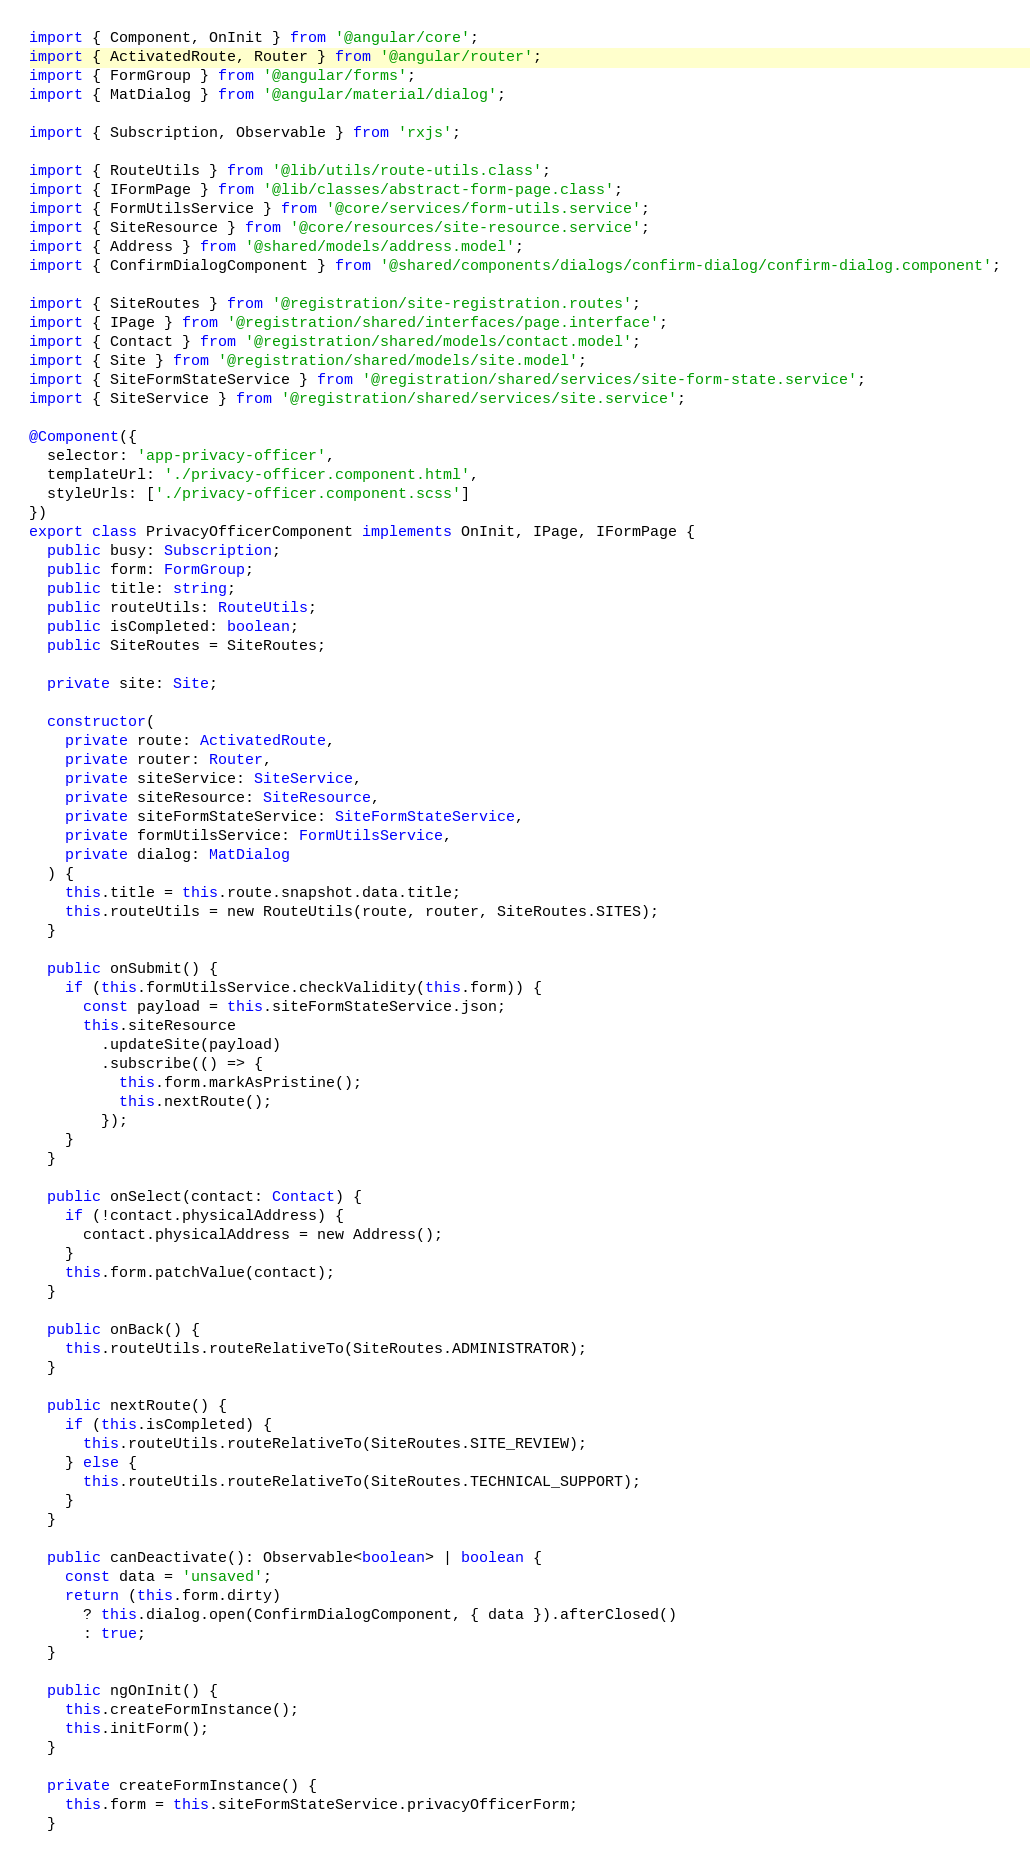Convert code to text. <code><loc_0><loc_0><loc_500><loc_500><_TypeScript_>import { Component, OnInit } from '@angular/core';
import { ActivatedRoute, Router } from '@angular/router';
import { FormGroup } from '@angular/forms';
import { MatDialog } from '@angular/material/dialog';

import { Subscription, Observable } from 'rxjs';

import { RouteUtils } from '@lib/utils/route-utils.class';
import { IFormPage } from '@lib/classes/abstract-form-page.class';
import { FormUtilsService } from '@core/services/form-utils.service';
import { SiteResource } from '@core/resources/site-resource.service';
import { Address } from '@shared/models/address.model';
import { ConfirmDialogComponent } from '@shared/components/dialogs/confirm-dialog/confirm-dialog.component';

import { SiteRoutes } from '@registration/site-registration.routes';
import { IPage } from '@registration/shared/interfaces/page.interface';
import { Contact } from '@registration/shared/models/contact.model';
import { Site } from '@registration/shared/models/site.model';
import { SiteFormStateService } from '@registration/shared/services/site-form-state.service';
import { SiteService } from '@registration/shared/services/site.service';

@Component({
  selector: 'app-privacy-officer',
  templateUrl: './privacy-officer.component.html',
  styleUrls: ['./privacy-officer.component.scss']
})
export class PrivacyOfficerComponent implements OnInit, IPage, IFormPage {
  public busy: Subscription;
  public form: FormGroup;
  public title: string;
  public routeUtils: RouteUtils;
  public isCompleted: boolean;
  public SiteRoutes = SiteRoutes;

  private site: Site;

  constructor(
    private route: ActivatedRoute,
    private router: Router,
    private siteService: SiteService,
    private siteResource: SiteResource,
    private siteFormStateService: SiteFormStateService,
    private formUtilsService: FormUtilsService,
    private dialog: MatDialog
  ) {
    this.title = this.route.snapshot.data.title;
    this.routeUtils = new RouteUtils(route, router, SiteRoutes.SITES);
  }

  public onSubmit() {
    if (this.formUtilsService.checkValidity(this.form)) {
      const payload = this.siteFormStateService.json;
      this.siteResource
        .updateSite(payload)
        .subscribe(() => {
          this.form.markAsPristine();
          this.nextRoute();
        });
    }
  }

  public onSelect(contact: Contact) {
    if (!contact.physicalAddress) {
      contact.physicalAddress = new Address();
    }
    this.form.patchValue(contact);
  }

  public onBack() {
    this.routeUtils.routeRelativeTo(SiteRoutes.ADMINISTRATOR);
  }

  public nextRoute() {
    if (this.isCompleted) {
      this.routeUtils.routeRelativeTo(SiteRoutes.SITE_REVIEW);
    } else {
      this.routeUtils.routeRelativeTo(SiteRoutes.TECHNICAL_SUPPORT);
    }
  }

  public canDeactivate(): Observable<boolean> | boolean {
    const data = 'unsaved';
    return (this.form.dirty)
      ? this.dialog.open(ConfirmDialogComponent, { data }).afterClosed()
      : true;
  }

  public ngOnInit() {
    this.createFormInstance();
    this.initForm();
  }

  private createFormInstance() {
    this.form = this.siteFormStateService.privacyOfficerForm;
  }
</code> 